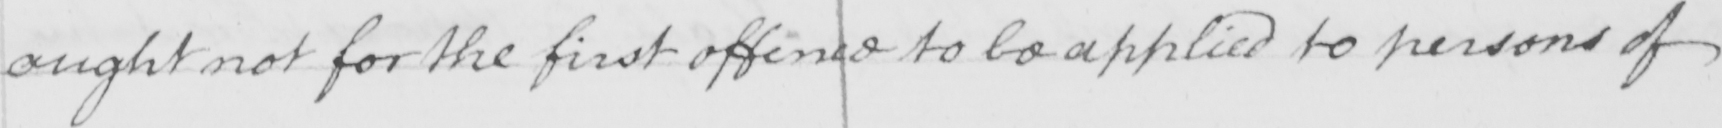Transcribe the text shown in this historical manuscript line. ought not for the first offence to be applied to persons of 